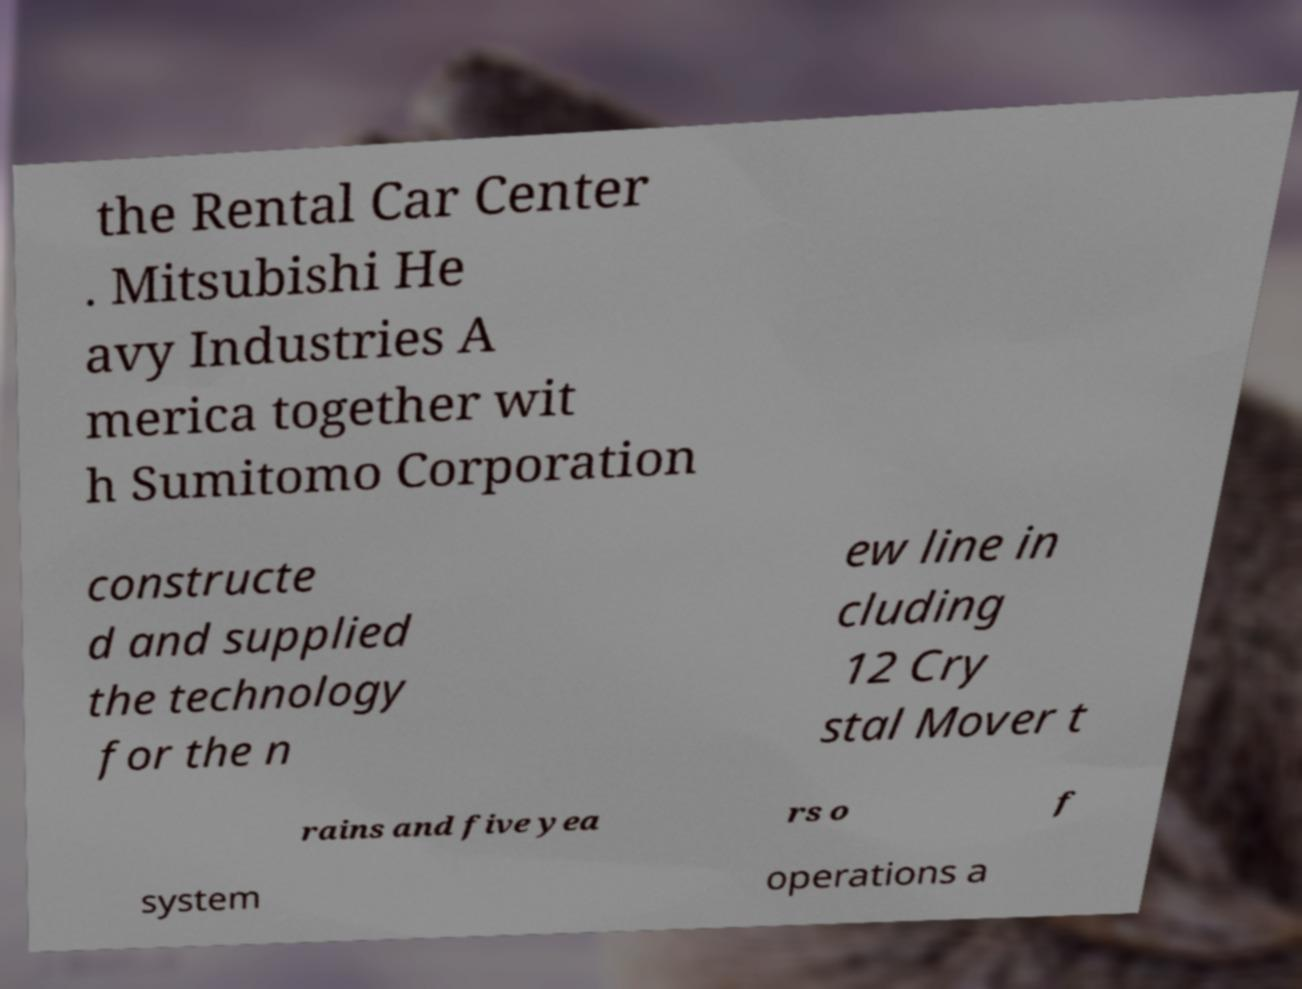Please identify and transcribe the text found in this image. the Rental Car Center . Mitsubishi He avy Industries A merica together wit h Sumitomo Corporation constructe d and supplied the technology for the n ew line in cluding 12 Cry stal Mover t rains and five yea rs o f system operations a 